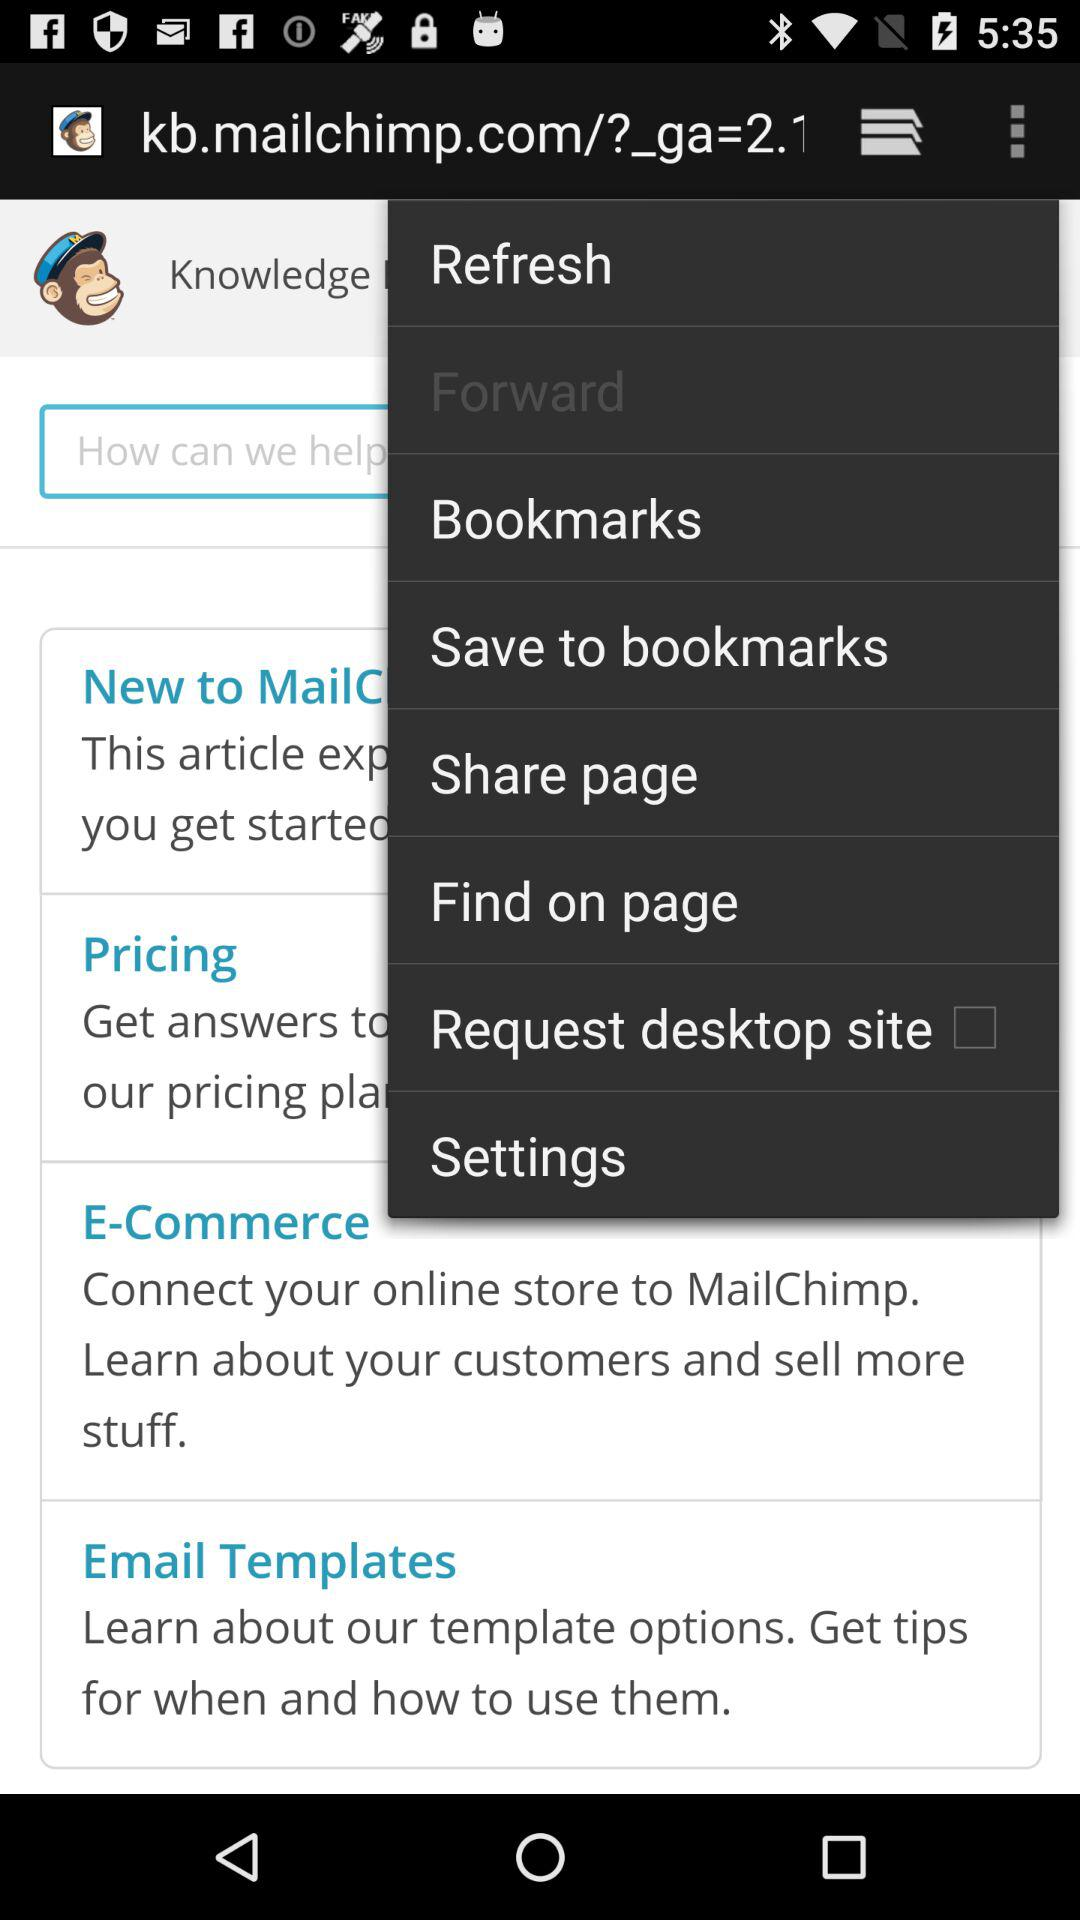What is the selected option? The selected option is "Forward". 